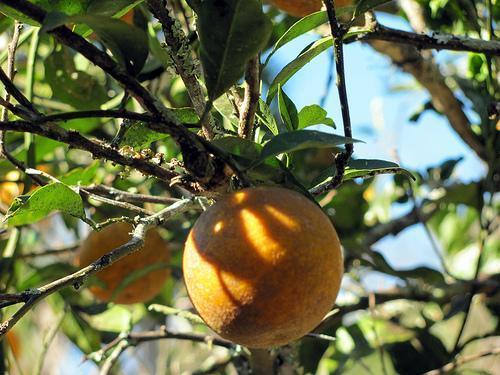How many oranges are in the picture?
Give a very brief answer. 6. 